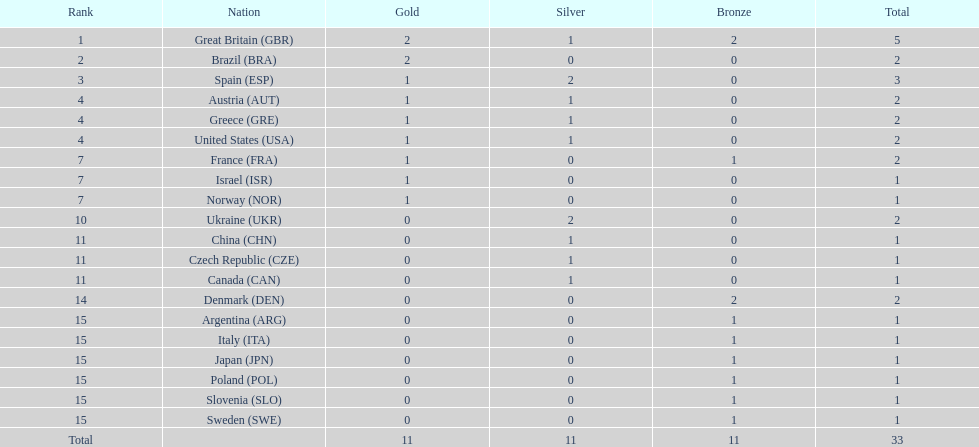What country had the most medals? Great Britain. Would you be able to parse every entry in this table? {'header': ['Rank', 'Nation', 'Gold', 'Silver', 'Bronze', 'Total'], 'rows': [['1', 'Great Britain\xa0(GBR)', '2', '1', '2', '5'], ['2', 'Brazil\xa0(BRA)', '2', '0', '0', '2'], ['3', 'Spain\xa0(ESP)', '1', '2', '0', '3'], ['4', 'Austria\xa0(AUT)', '1', '1', '0', '2'], ['4', 'Greece\xa0(GRE)', '1', '1', '0', '2'], ['4', 'United States\xa0(USA)', '1', '1', '0', '2'], ['7', 'France\xa0(FRA)', '1', '0', '1', '2'], ['7', 'Israel\xa0(ISR)', '1', '0', '0', '1'], ['7', 'Norway\xa0(NOR)', '1', '0', '0', '1'], ['10', 'Ukraine\xa0(UKR)', '0', '2', '0', '2'], ['11', 'China\xa0(CHN)', '0', '1', '0', '1'], ['11', 'Czech Republic\xa0(CZE)', '0', '1', '0', '1'], ['11', 'Canada\xa0(CAN)', '0', '1', '0', '1'], ['14', 'Denmark\xa0(DEN)', '0', '0', '2', '2'], ['15', 'Argentina\xa0(ARG)', '0', '0', '1', '1'], ['15', 'Italy\xa0(ITA)', '0', '0', '1', '1'], ['15', 'Japan\xa0(JPN)', '0', '0', '1', '1'], ['15', 'Poland\xa0(POL)', '0', '0', '1', '1'], ['15', 'Slovenia\xa0(SLO)', '0', '0', '1', '1'], ['15', 'Sweden\xa0(SWE)', '0', '0', '1', '1'], ['Total', '', '11', '11', '11', '33']]} 